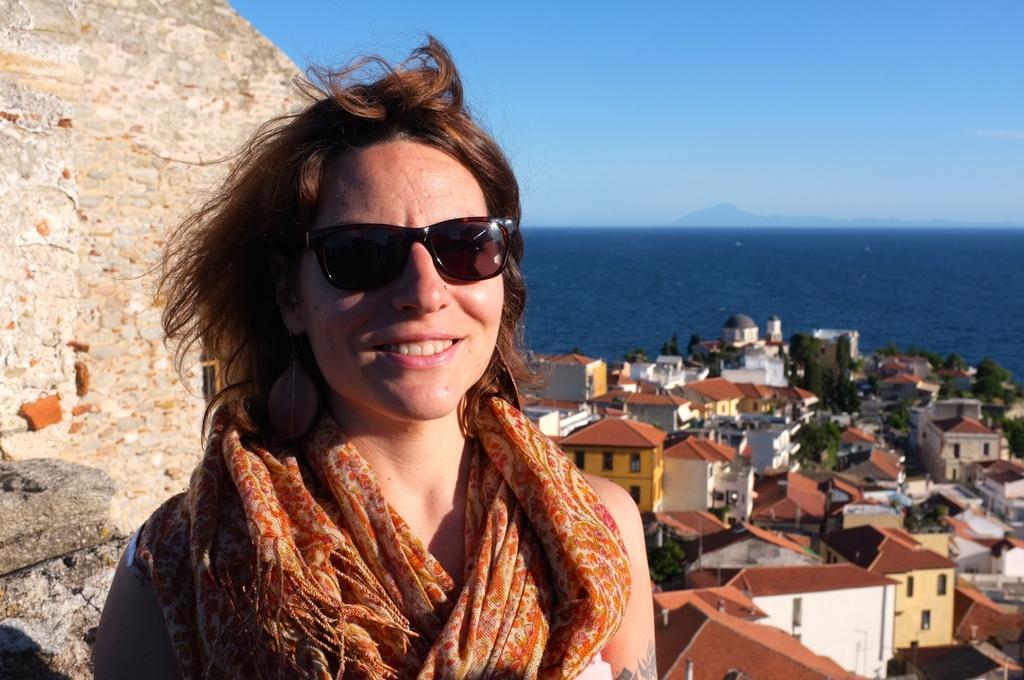Please provide a concise description of this image. In the front of the image I can see a woman wore a scarf and goggles. In the background of the image I can see water, buildings, trees, wall and sky.   